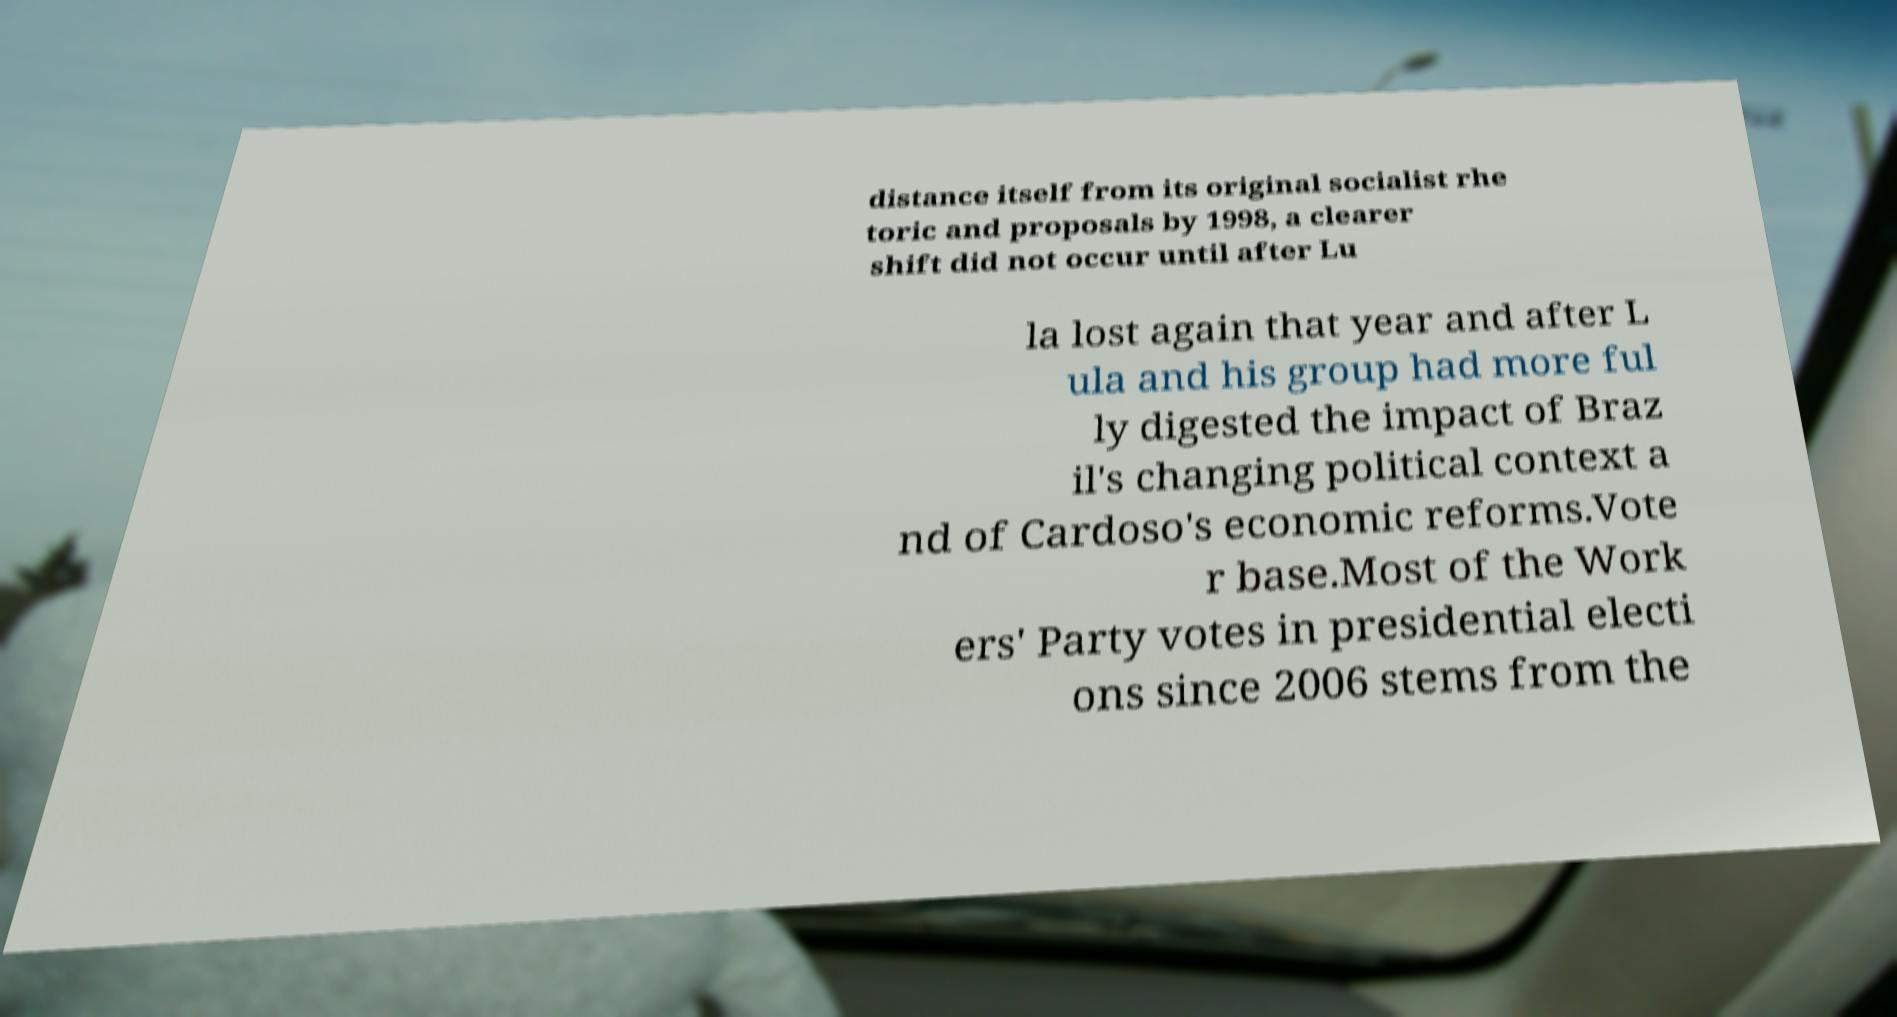Could you assist in decoding the text presented in this image and type it out clearly? distance itself from its original socialist rhe toric and proposals by 1998, a clearer shift did not occur until after Lu la lost again that year and after L ula and his group had more ful ly digested the impact of Braz il's changing political context a nd of Cardoso's economic reforms.Vote r base.Most of the Work ers' Party votes in presidential electi ons since 2006 stems from the 